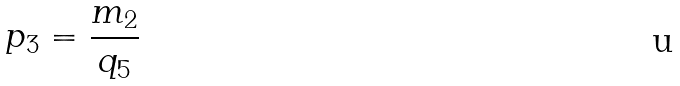<formula> <loc_0><loc_0><loc_500><loc_500>p _ { 3 } = \frac { m _ { 2 } } { q _ { 5 } }</formula> 